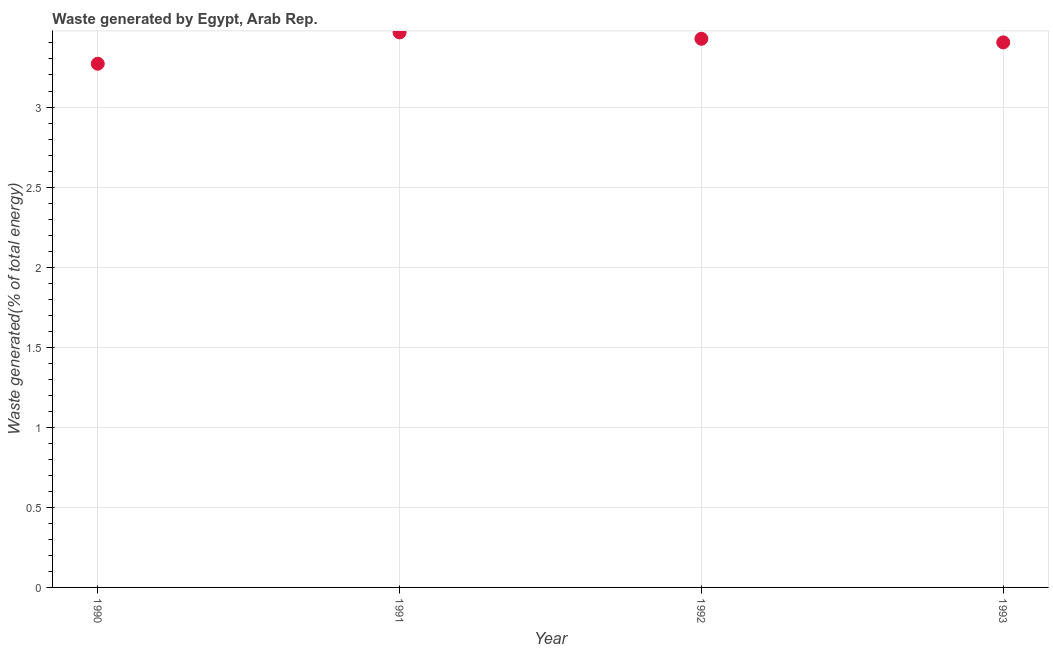What is the amount of waste generated in 1991?
Ensure brevity in your answer.  3.47. Across all years, what is the maximum amount of waste generated?
Your answer should be compact. 3.47. Across all years, what is the minimum amount of waste generated?
Your response must be concise. 3.27. In which year was the amount of waste generated minimum?
Your answer should be very brief. 1990. What is the sum of the amount of waste generated?
Your answer should be compact. 13.57. What is the difference between the amount of waste generated in 1991 and 1993?
Your answer should be compact. 0.06. What is the average amount of waste generated per year?
Provide a short and direct response. 3.39. What is the median amount of waste generated?
Offer a very short reply. 3.41. Do a majority of the years between 1990 and 1993 (inclusive) have amount of waste generated greater than 2 %?
Your answer should be very brief. Yes. What is the ratio of the amount of waste generated in 1992 to that in 1993?
Your response must be concise. 1.01. Is the amount of waste generated in 1991 less than that in 1993?
Keep it short and to the point. No. What is the difference between the highest and the second highest amount of waste generated?
Your response must be concise. 0.04. Is the sum of the amount of waste generated in 1991 and 1992 greater than the maximum amount of waste generated across all years?
Make the answer very short. Yes. What is the difference between the highest and the lowest amount of waste generated?
Make the answer very short. 0.2. Does the amount of waste generated monotonically increase over the years?
Offer a terse response. No. Does the graph contain any zero values?
Your response must be concise. No. What is the title of the graph?
Your response must be concise. Waste generated by Egypt, Arab Rep. What is the label or title of the X-axis?
Your answer should be very brief. Year. What is the label or title of the Y-axis?
Provide a succinct answer. Waste generated(% of total energy). What is the Waste generated(% of total energy) in 1990?
Keep it short and to the point. 3.27. What is the Waste generated(% of total energy) in 1991?
Give a very brief answer. 3.47. What is the Waste generated(% of total energy) in 1992?
Make the answer very short. 3.43. What is the Waste generated(% of total energy) in 1993?
Ensure brevity in your answer.  3.4. What is the difference between the Waste generated(% of total energy) in 1990 and 1991?
Offer a terse response. -0.2. What is the difference between the Waste generated(% of total energy) in 1990 and 1992?
Provide a succinct answer. -0.16. What is the difference between the Waste generated(% of total energy) in 1990 and 1993?
Ensure brevity in your answer.  -0.13. What is the difference between the Waste generated(% of total energy) in 1991 and 1992?
Give a very brief answer. 0.04. What is the difference between the Waste generated(% of total energy) in 1991 and 1993?
Offer a terse response. 0.06. What is the difference between the Waste generated(% of total energy) in 1992 and 1993?
Make the answer very short. 0.02. What is the ratio of the Waste generated(% of total energy) in 1990 to that in 1991?
Provide a short and direct response. 0.94. What is the ratio of the Waste generated(% of total energy) in 1990 to that in 1992?
Keep it short and to the point. 0.95. What is the ratio of the Waste generated(% of total energy) in 1990 to that in 1993?
Your answer should be very brief. 0.96. What is the ratio of the Waste generated(% of total energy) in 1991 to that in 1992?
Provide a short and direct response. 1.01. What is the ratio of the Waste generated(% of total energy) in 1992 to that in 1993?
Provide a short and direct response. 1.01. 